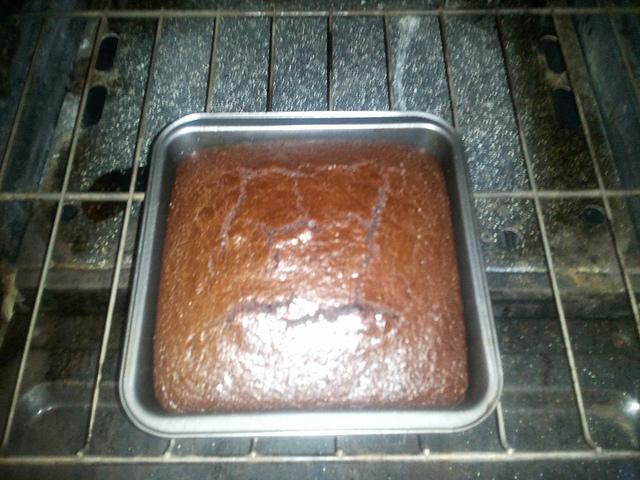Is this an oven?
Write a very short answer. Yes. Why is the desert cracked?
Short answer required. Hot. How many bars are on this oven rack?
Keep it brief. 11. 